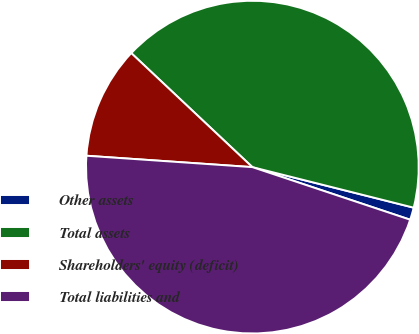Convert chart to OTSL. <chart><loc_0><loc_0><loc_500><loc_500><pie_chart><fcel>Other assets<fcel>Total assets<fcel>Shareholders' equity (deficit)<fcel>Total liabilities and<nl><fcel>1.2%<fcel>41.9%<fcel>10.93%<fcel>45.97%<nl></chart> 